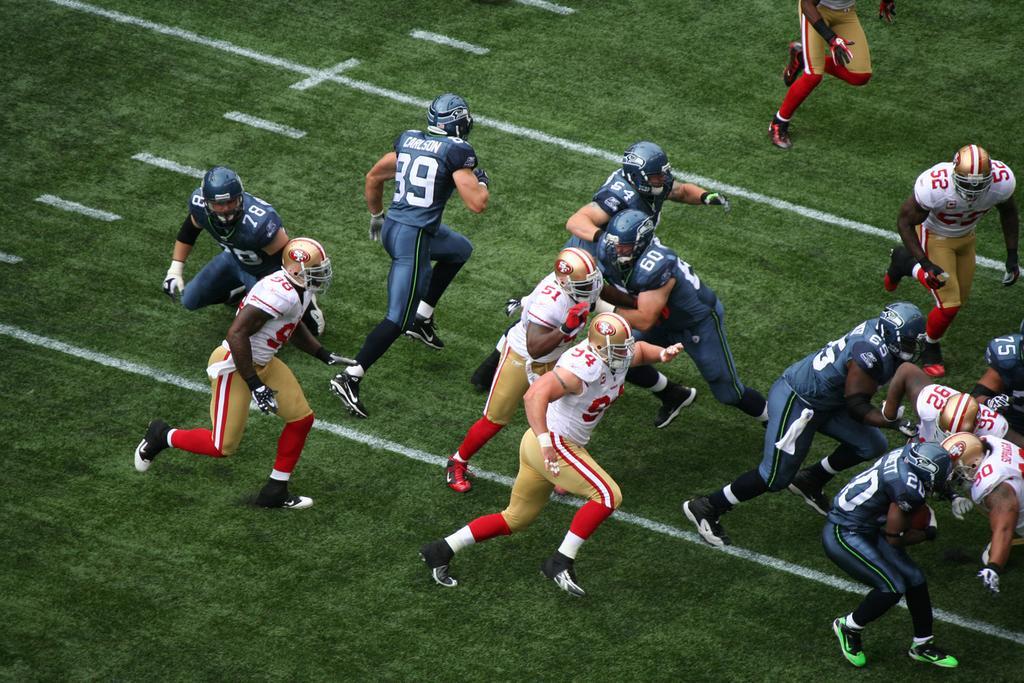Please provide a concise description of this image. In this image we can see people playing american football. At the bottom of the image there is grass. 